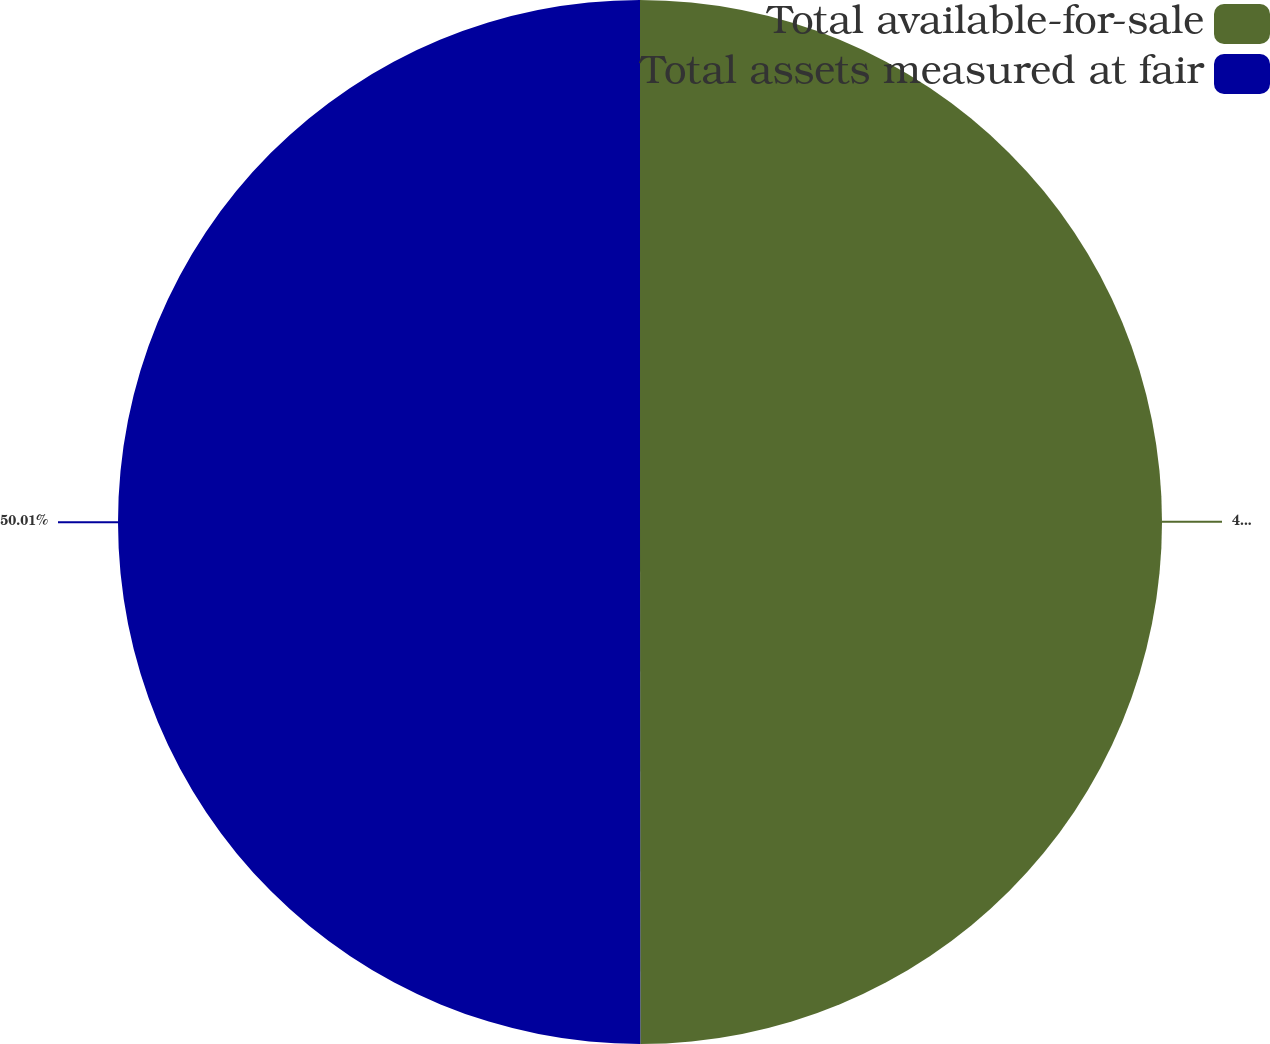<chart> <loc_0><loc_0><loc_500><loc_500><pie_chart><fcel>Total available-for-sale<fcel>Total assets measured at fair<nl><fcel>49.99%<fcel>50.01%<nl></chart> 